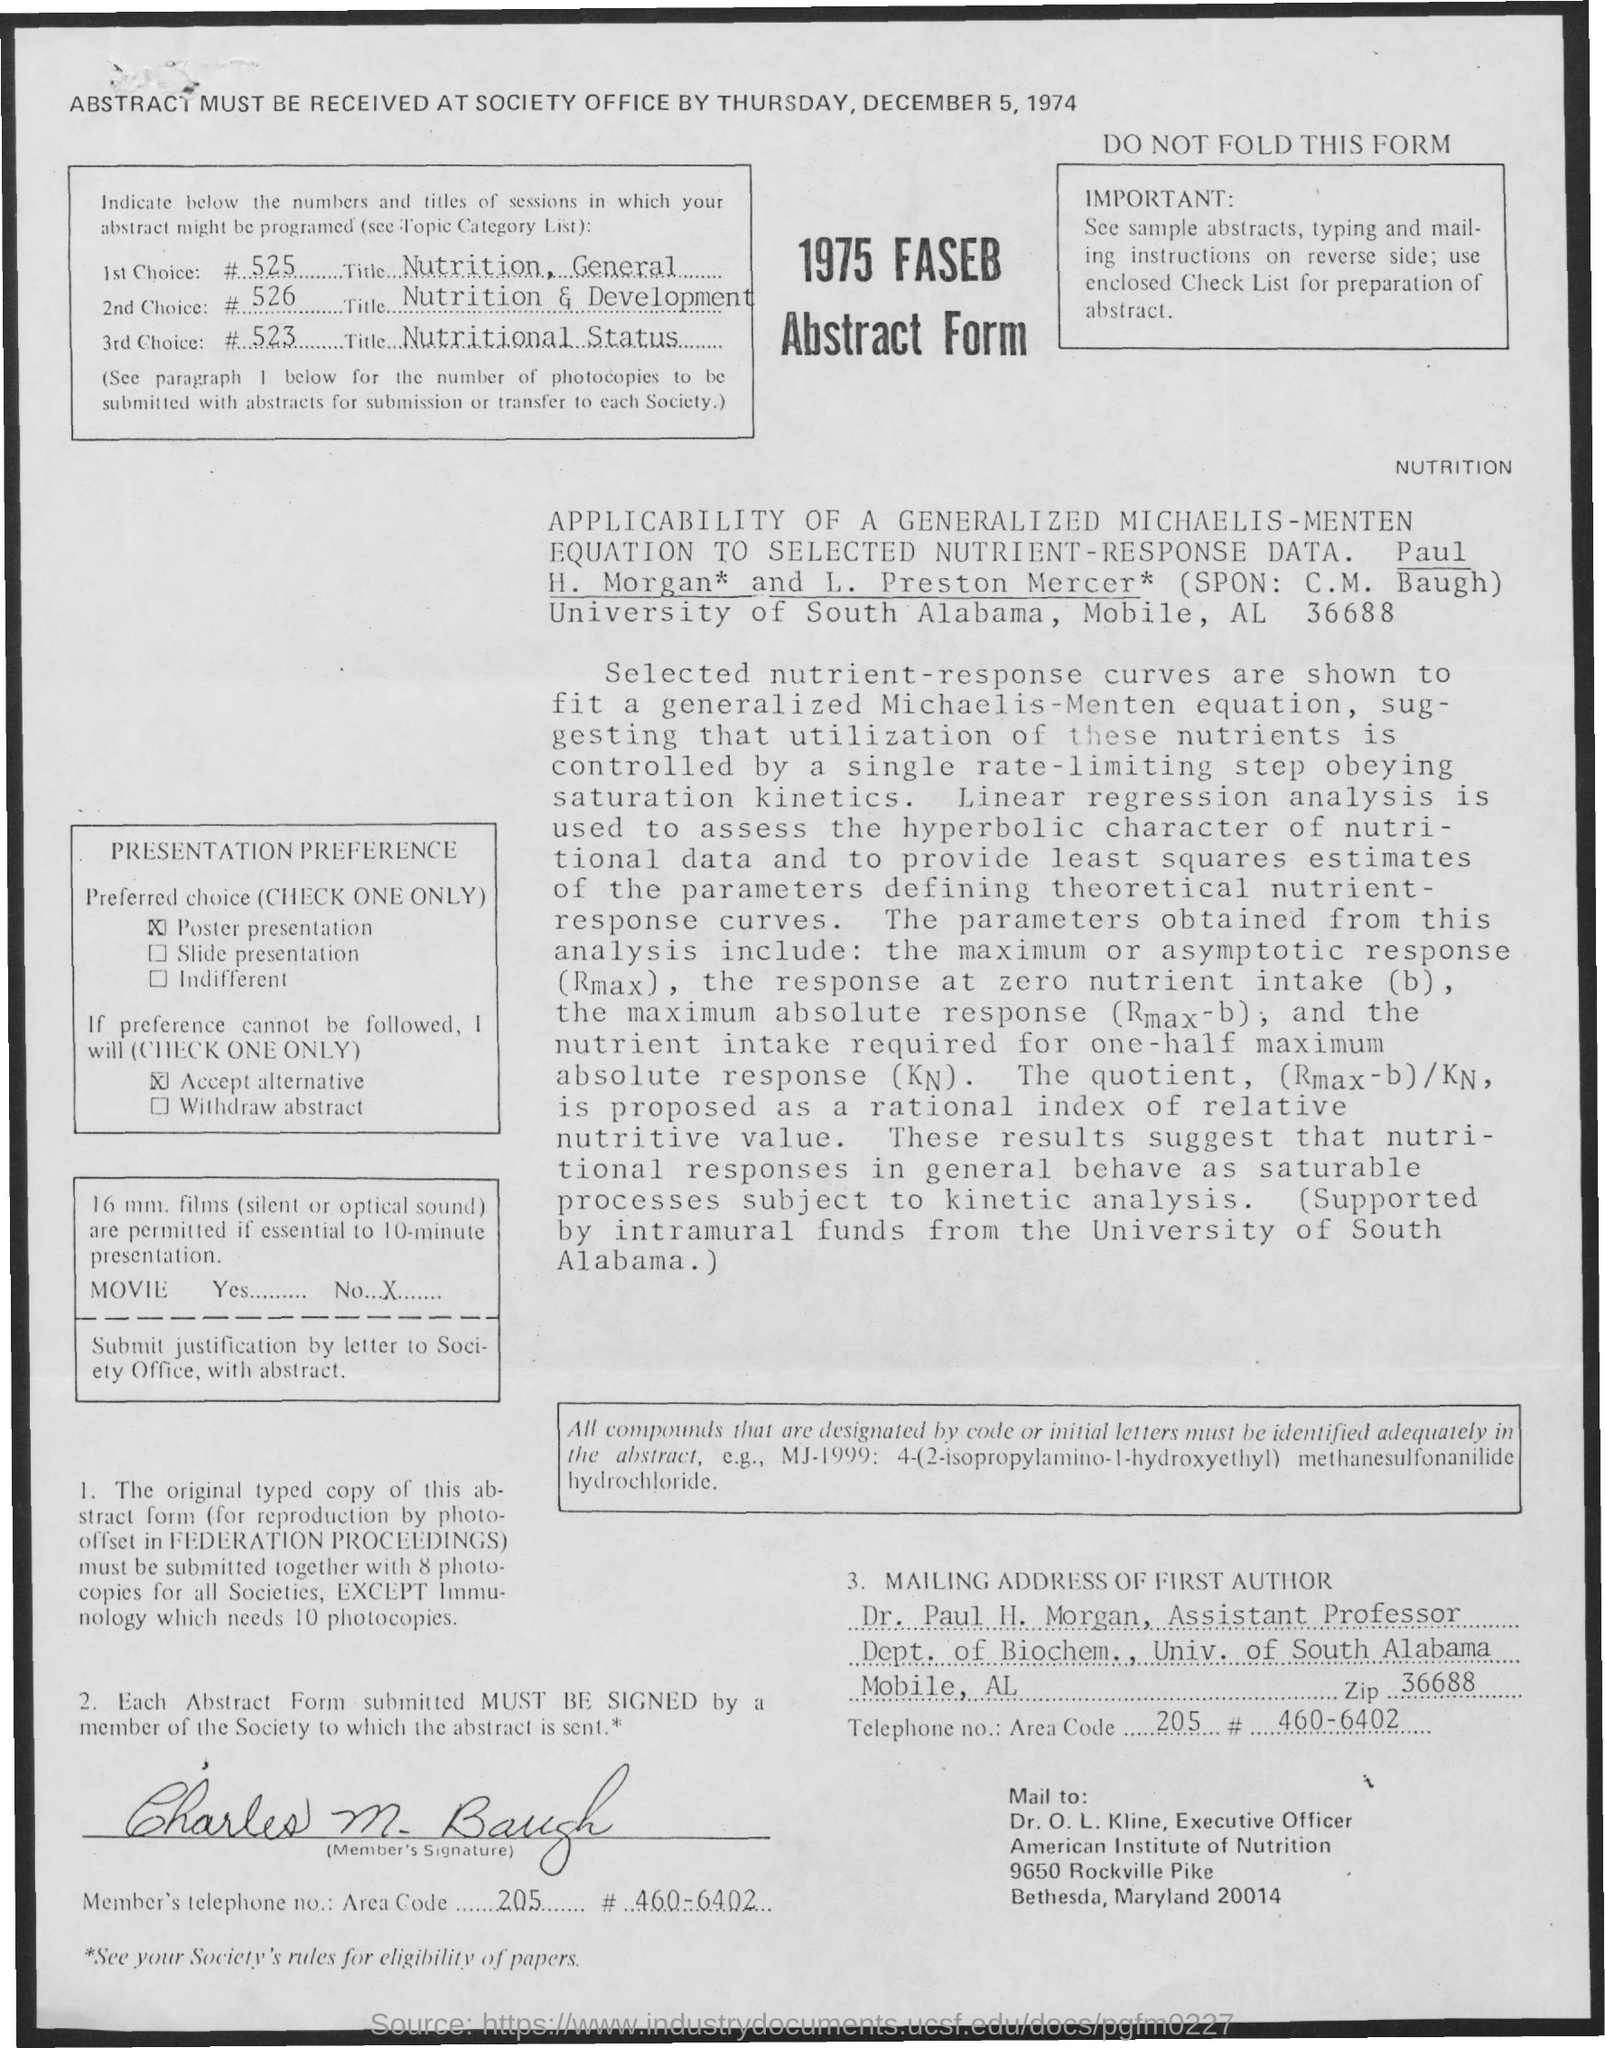Point out several critical features in this image. The first choice is entitled 'NUTRITION, GENERAL.' The abstract must be received on Thursday, December 5, 1974. The third option for the title is 'Nutritional Status'. The second choice is titled 'Nutrition and Development.' 